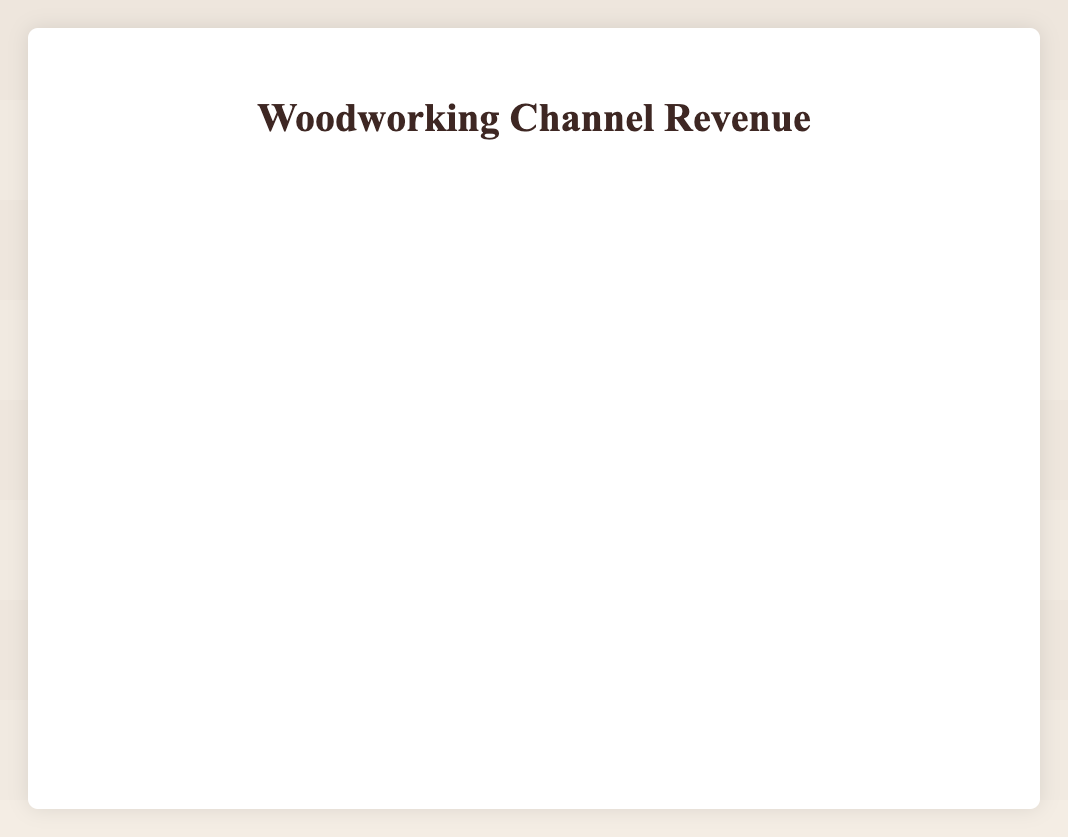What was the advertisement revenue for December 2022? The table shows that in December 2022, the advertisement revenue was reported as 3000.
Answer: 3000 In which month did the sponsorship revenue first exceed $2000? Looking through the sponsorship revenue column, it first exceeds $2000 in June 2023.
Answer: June 2023 What is the total advertisement revenue for the first six months of 2023? Summing the advertisement revenues from January to June 2023: 2800 + 3200 + 3500 + 3000 + 4000 + 4500 = 21000.
Answer: 21000 Was the sponsorship revenue for February 2022 higher than that of February 2023? In February 2022, the sponsorship revenue was 950, whereas in February 2023 it was 1600. Since 950 is less than 1600, the answer is no.
Answer: No What is the average advertisement revenue over the last year from October 2022 to September 2023? Summing the advertisement revenues from October 2022 (2300) to September 2023 (5300) gives: 2300 + 2500 + 3000 + 2800 + 3200 + 3500 + 3000 + 4000 + 4500 + 5000 + 4800 + 5300 = 36800. There are 12 months, so the average is 36800/12 = 3066.67.
Answer: 3066.67 During what period did the sponsorship revenue experience the most significant month-to-month increase? Reviewing the sponsorship revenue from month to month, the largest increase happens between July 2023 (2200) and August 2023 (2100), where the difference is 100.
Answer: Between July and August 2023 What is the difference between the highest and lowest monthly advertisement revenue recorded? From the table, the highest advertisement revenue is 6000 in October 2023 and the lowest is 1200 in January 2022. Therefore, the difference is 6000 - 1200 = 4800.
Answer: 4800 Did advertisement revenue grow consistently each month from January 2022 to October 2023? By examining the data, advertisement revenue did not grow consistently each month; there were fluctuations, such as a decrease in April 2023 compared to March 2023.
Answer: No 